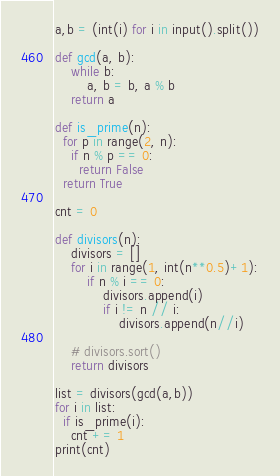<code> <loc_0><loc_0><loc_500><loc_500><_Python_>a,b = (int(i) for i in input().split())

def gcd(a, b):
    while b:
        a, b = b, a % b
    return a
  
def is_prime(n):
  for p in range(2, n):
    if n % p == 0:
      return False
  return True

cnt = 0

def divisors(n):
    divisors = []
    for i in range(1, int(n**0.5)+1):
        if n % i == 0:
            divisors.append(i)
            if i != n // i:
                divisors.append(n//i)

    # divisors.sort()
    return divisors
  
list = divisors(gcd(a,b))
for i in list:
  if is_prime(i):
    cnt += 1
print(cnt)</code> 